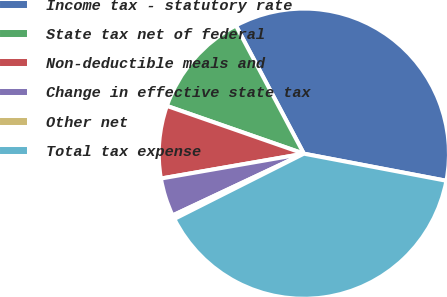Convert chart to OTSL. <chart><loc_0><loc_0><loc_500><loc_500><pie_chart><fcel>Income tax - statutory rate<fcel>State tax net of federal<fcel>Non-deductible meals and<fcel>Change in effective state tax<fcel>Other net<fcel>Total tax expense<nl><fcel>35.75%<fcel>11.9%<fcel>8.08%<fcel>4.26%<fcel>0.43%<fcel>39.58%<nl></chart> 